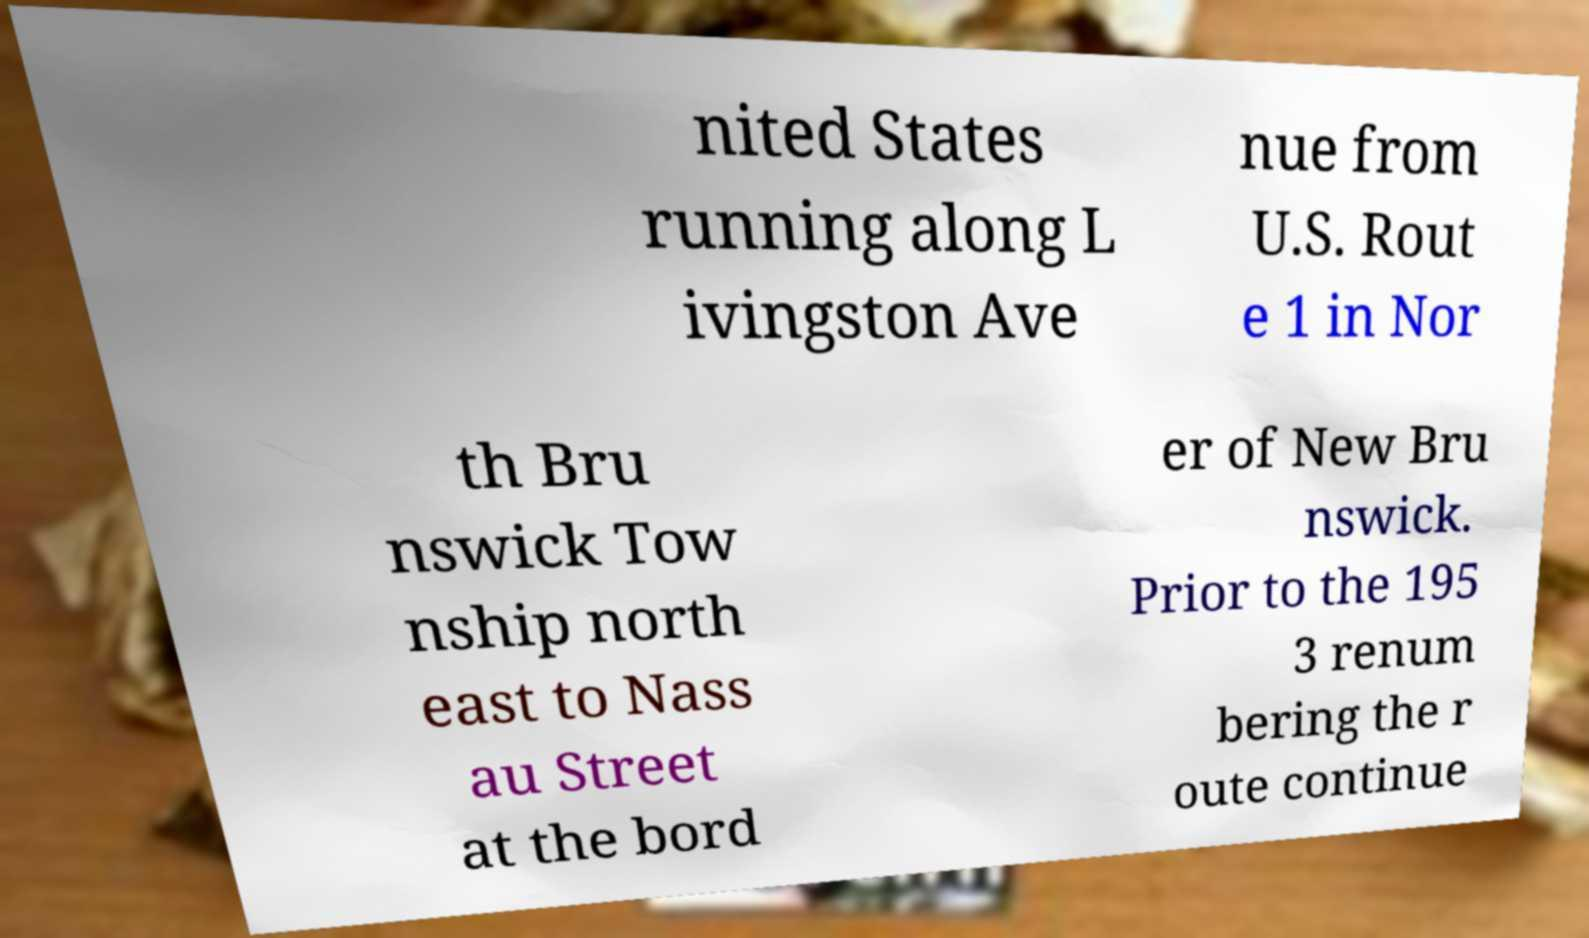There's text embedded in this image that I need extracted. Can you transcribe it verbatim? nited States running along L ivingston Ave nue from U.S. Rout e 1 in Nor th Bru nswick Tow nship north east to Nass au Street at the bord er of New Bru nswick. Prior to the 195 3 renum bering the r oute continue 